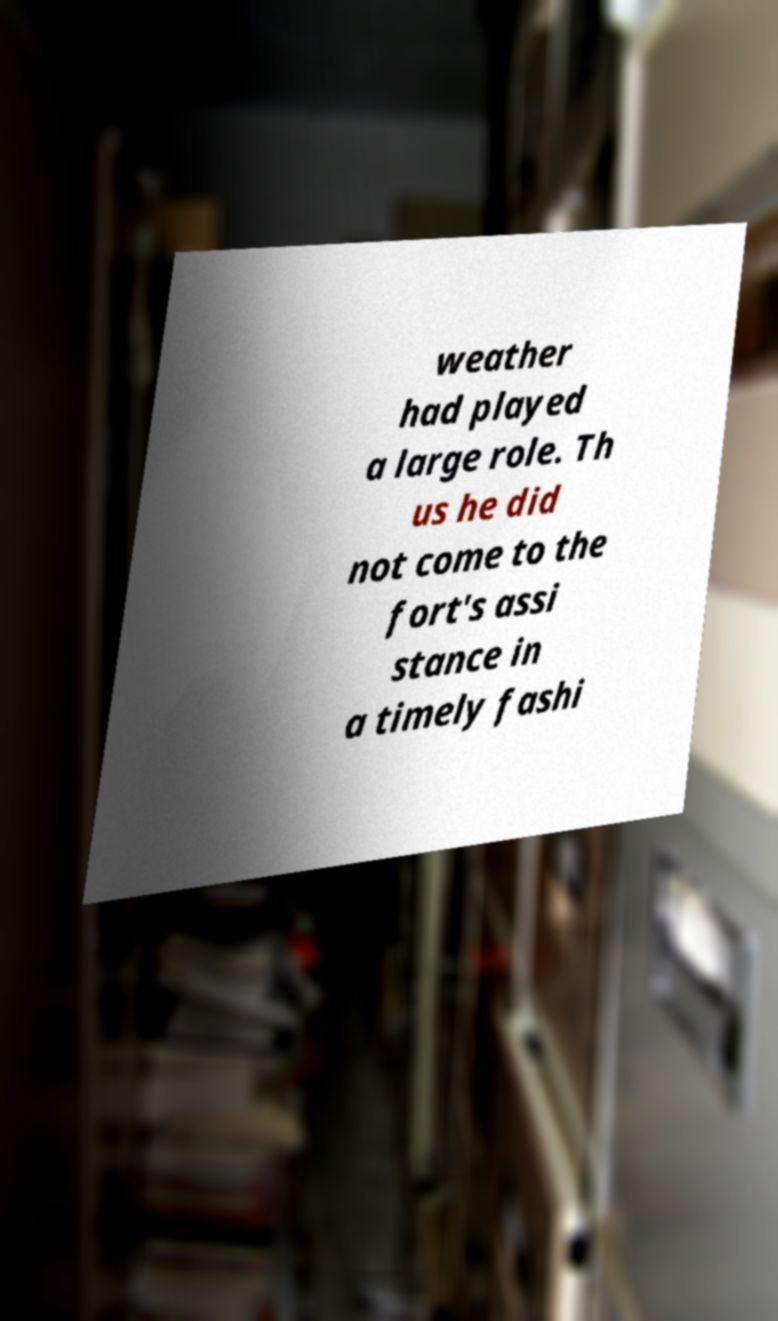What messages or text are displayed in this image? I need them in a readable, typed format. weather had played a large role. Th us he did not come to the fort's assi stance in a timely fashi 